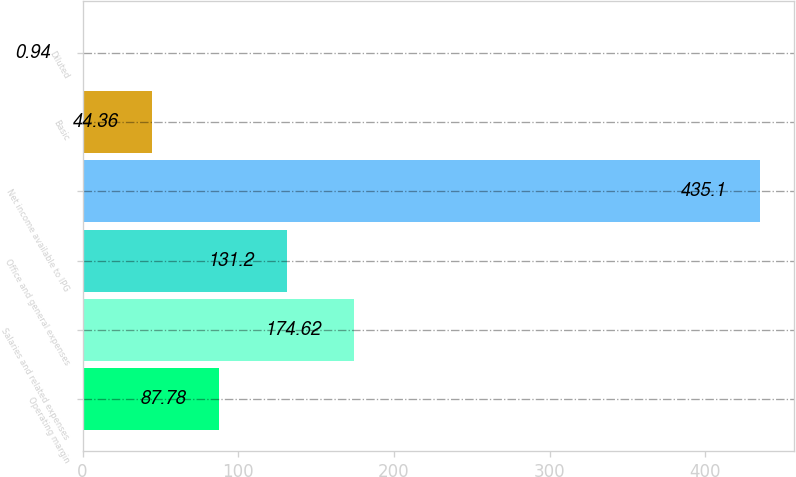Convert chart. <chart><loc_0><loc_0><loc_500><loc_500><bar_chart><fcel>Operating margin<fcel>Salaries and related expenses<fcel>Office and general expenses<fcel>Net income available to IPG<fcel>Basic<fcel>Diluted<nl><fcel>87.78<fcel>174.62<fcel>131.2<fcel>435.1<fcel>44.36<fcel>0.94<nl></chart> 